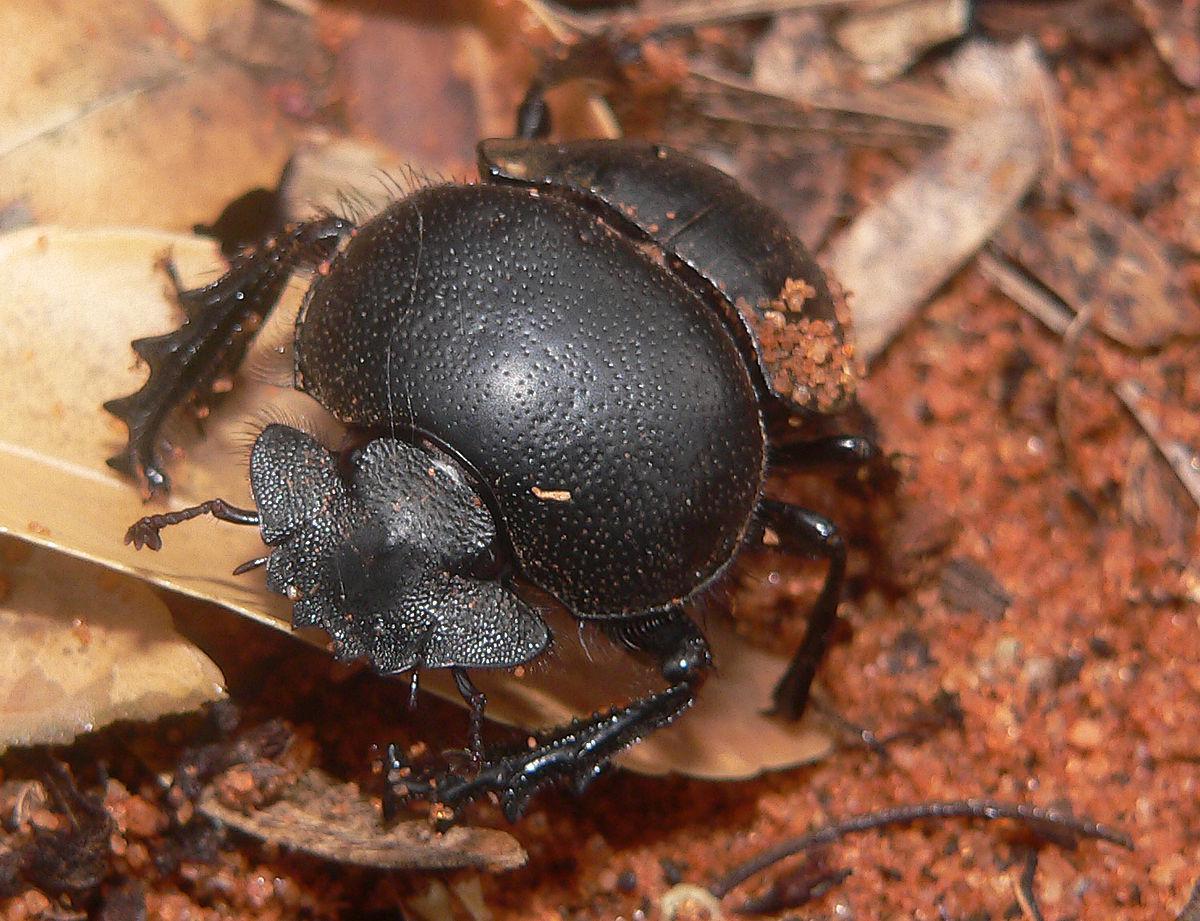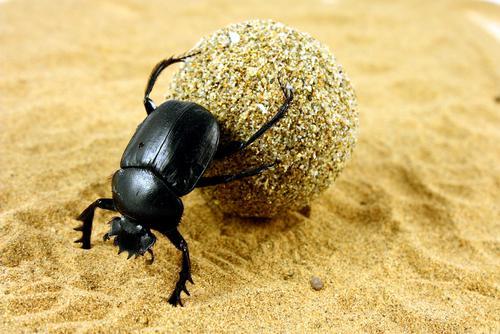The first image is the image on the left, the second image is the image on the right. For the images displayed, is the sentence "There are at least three beetles." factually correct? Answer yes or no. No. The first image is the image on the left, the second image is the image on the right. Evaluate the accuracy of this statement regarding the images: "One dung beetle is completely on top of a piece of wood.". Is it true? Answer yes or no. No. 